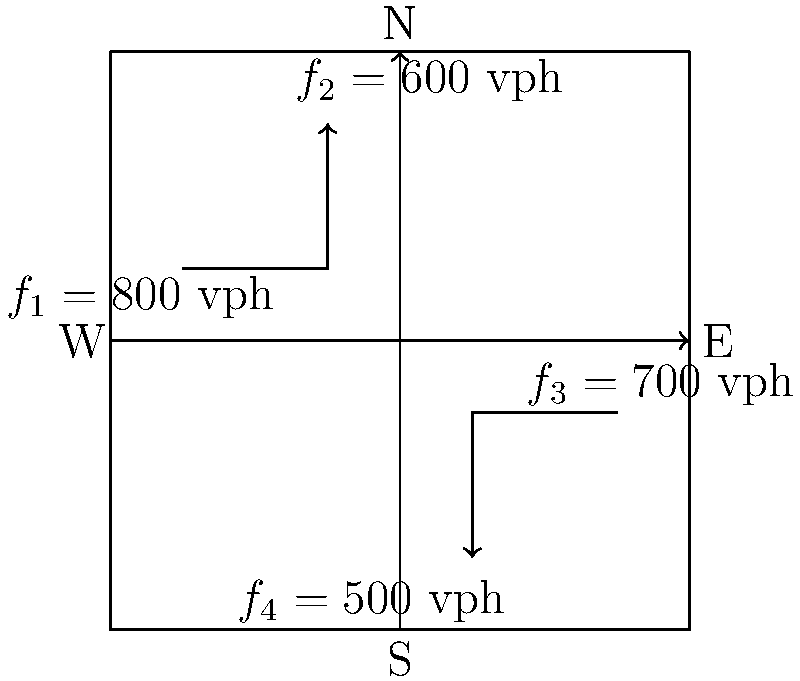At a complex urban intersection, traffic flow rates (in vehicles per hour) are measured for each direction as shown in the diagram. Assuming a 120-second signal cycle, what is the minimum green time (in seconds) required for the east-west direction to clear all vehicles, given that the saturation flow rate is 1800 vehicles per hour per lane? To solve this problem, we'll follow these steps:

1. Identify the relevant traffic flows:
   East-west direction: $f_1 = 800$ vph and $f_3 = 700$ vph

2. Calculate the total flow for the east-west direction:
   $f_{total} = f_1 + f_3 = 800 + 700 = 1500$ vph

3. Convert the total flow to vehicles per cycle:
   Cycle length = 120 seconds
   Vehicles per cycle = $\frac{f_{total}}{3600} \times 120 = \frac{1500}{3600} \times 120 = 50$ vehicles

4. Calculate the time needed to clear these vehicles:
   Saturation flow rate = 1800 vph per lane
   Vehicles cleared per second = $\frac{1800}{3600} = 0.5$ vehicles/second

   Time needed = $\frac{\text{Vehicles per cycle}}{\text{Vehicles cleared per second}} = \frac{50}{0.5} = 100$ seconds

Therefore, the minimum green time required for the east-west direction is 100 seconds.
Answer: 100 seconds 